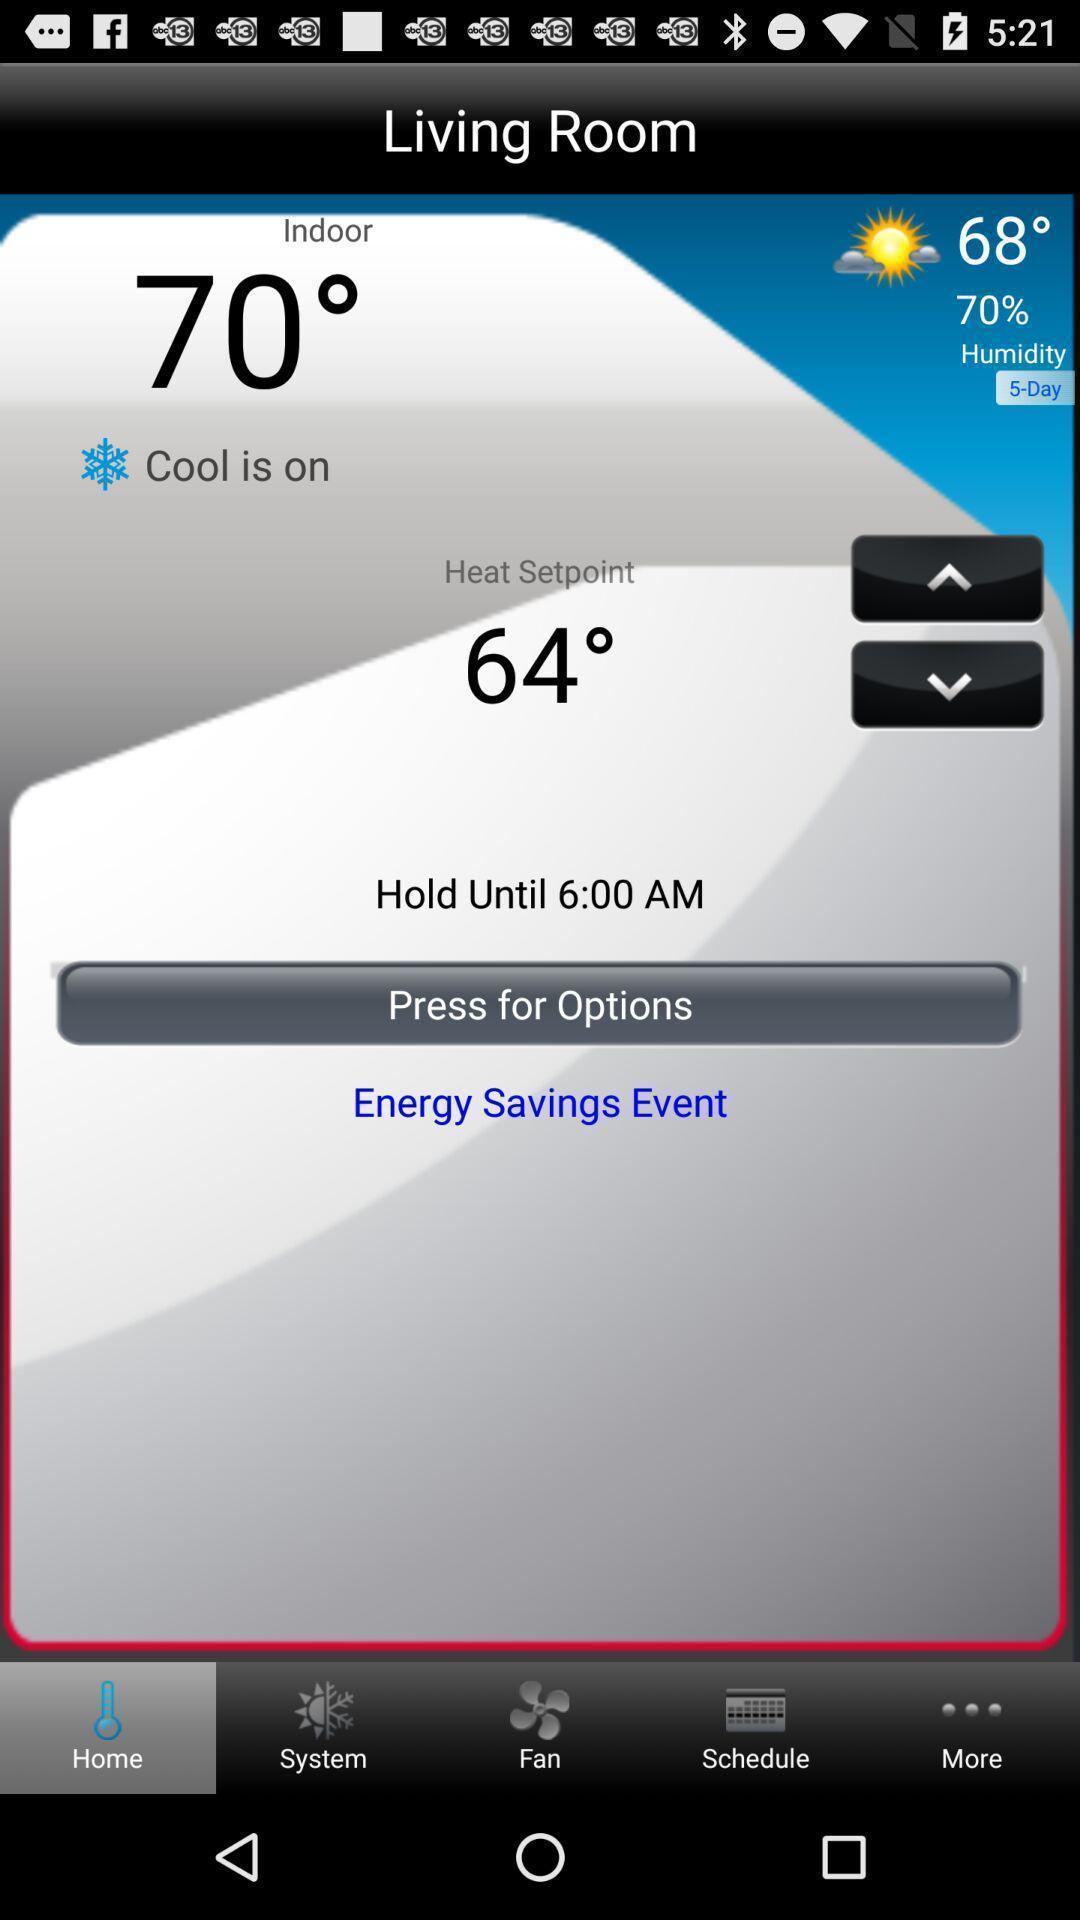Give me a summary of this screen capture. Screen displaying the home page. 